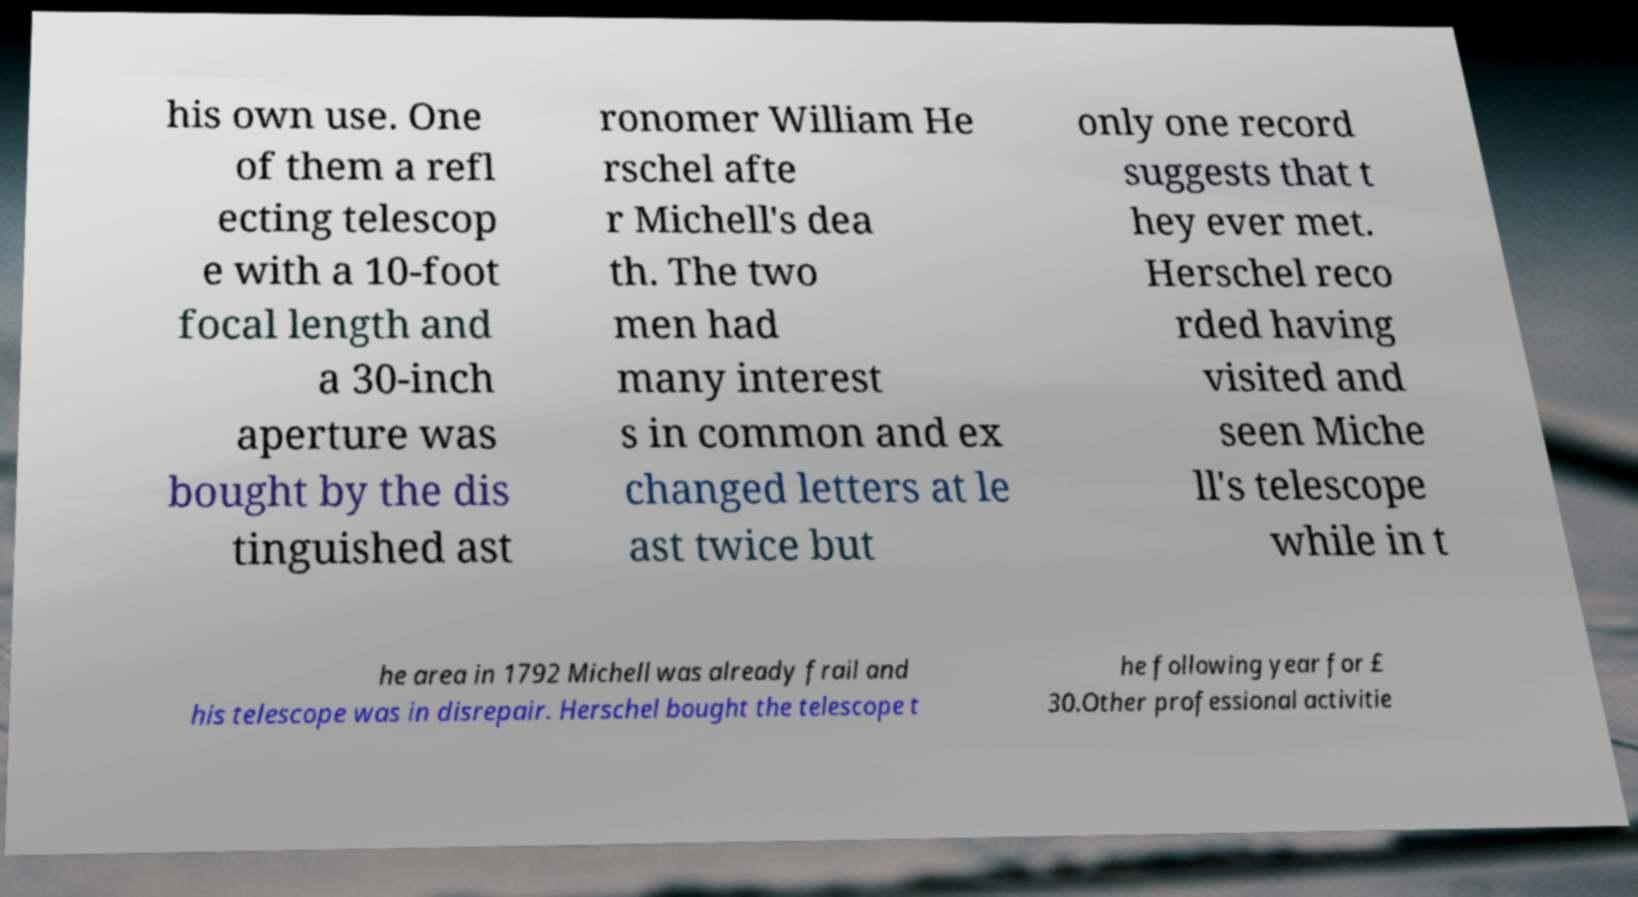Could you assist in decoding the text presented in this image and type it out clearly? his own use. One of them a refl ecting telescop e with a 10-foot focal length and a 30-inch aperture was bought by the dis tinguished ast ronomer William He rschel afte r Michell's dea th. The two men had many interest s in common and ex changed letters at le ast twice but only one record suggests that t hey ever met. Herschel reco rded having visited and seen Miche ll's telescope while in t he area in 1792 Michell was already frail and his telescope was in disrepair. Herschel bought the telescope t he following year for £ 30.Other professional activitie 